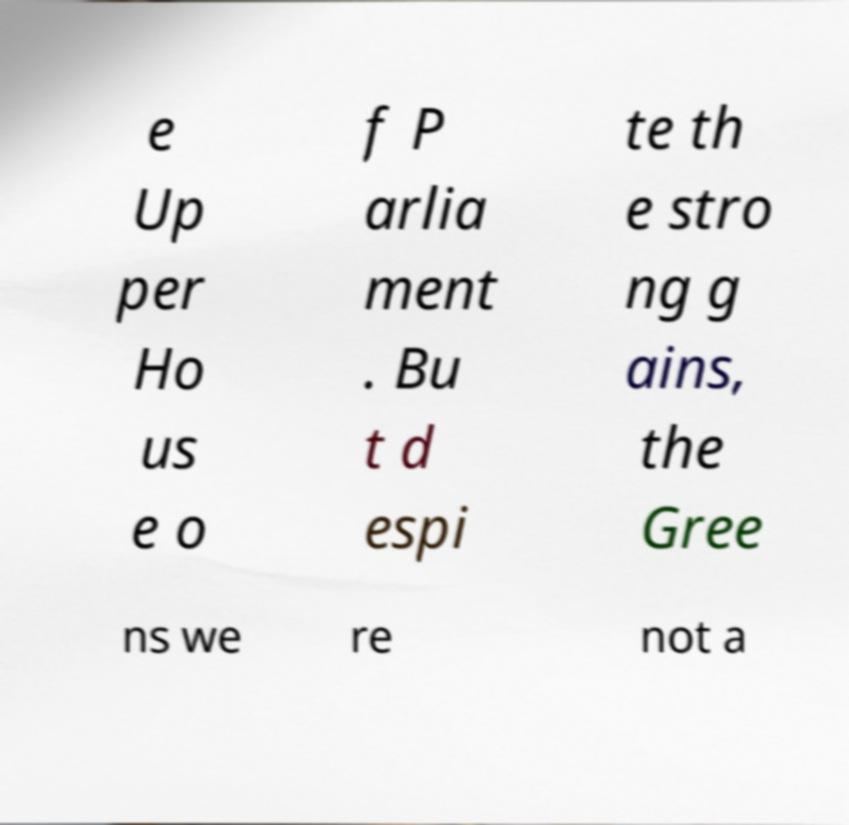Could you assist in decoding the text presented in this image and type it out clearly? e Up per Ho us e o f P arlia ment . Bu t d espi te th e stro ng g ains, the Gree ns we re not a 